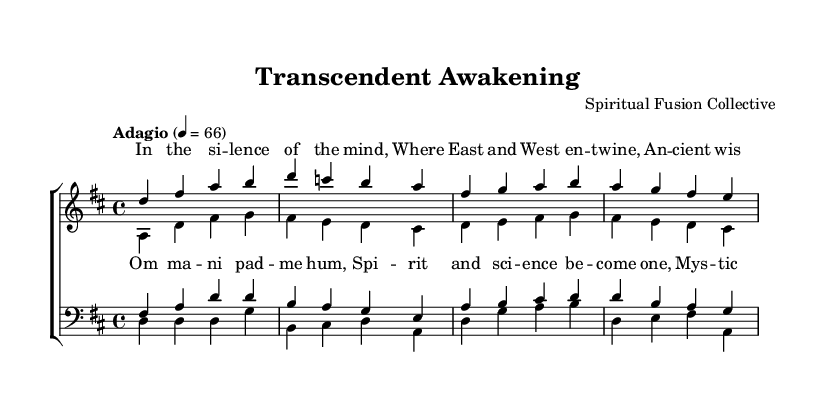What is the key signature of this music? The key signature is indicated at the beginning of the score, marking one sharp, which corresponds to D major.
Answer: D major What is the time signature of this music? The time signature is indicated in the initial part of the sheet music, showing a four over four, which means there are four beats in a measure.
Answer: 4/4 What is the tempo marking of this piece? The tempo is written above the staff indicating "Adagio" and a metronome marking of 4 = 66, indicating a slow pace.
Answer: Adagio How many voices are in the choral composition? Detecting the parts listed in the score, there are four distinct voices: soprano, alto, tenor, and bass, which together make the full choir.
Answer: Four What does the chorus contain? The chorus includes specific lyrics written in a separate lyric mode, indicating a thematic shift that is often central in choral works.
Answer: Om mani padme hum, Spirit and science become one, Mystic visions now unfold, Neural pathways to behold What is the primary theme explored in the lyrics? By analyzing both the verse and chorus, they emphasize the fusion of ancient wisdom and modern understanding, showcasing a blend of spirituality and scientific inquiry.
Answer: Transcendence How does the structure reflect Eastern spiritual themes? The use of "Om mani padme hum," a well-known mantra, signifies a direct connection to Eastern spiritual practices, indicating an integration of Eastern elements within a Western classical framework.
Answer: Mantra integration 